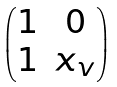Convert formula to latex. <formula><loc_0><loc_0><loc_500><loc_500>\begin{pmatrix} 1 & 0 \\ 1 & x _ { v } \end{pmatrix}</formula> 